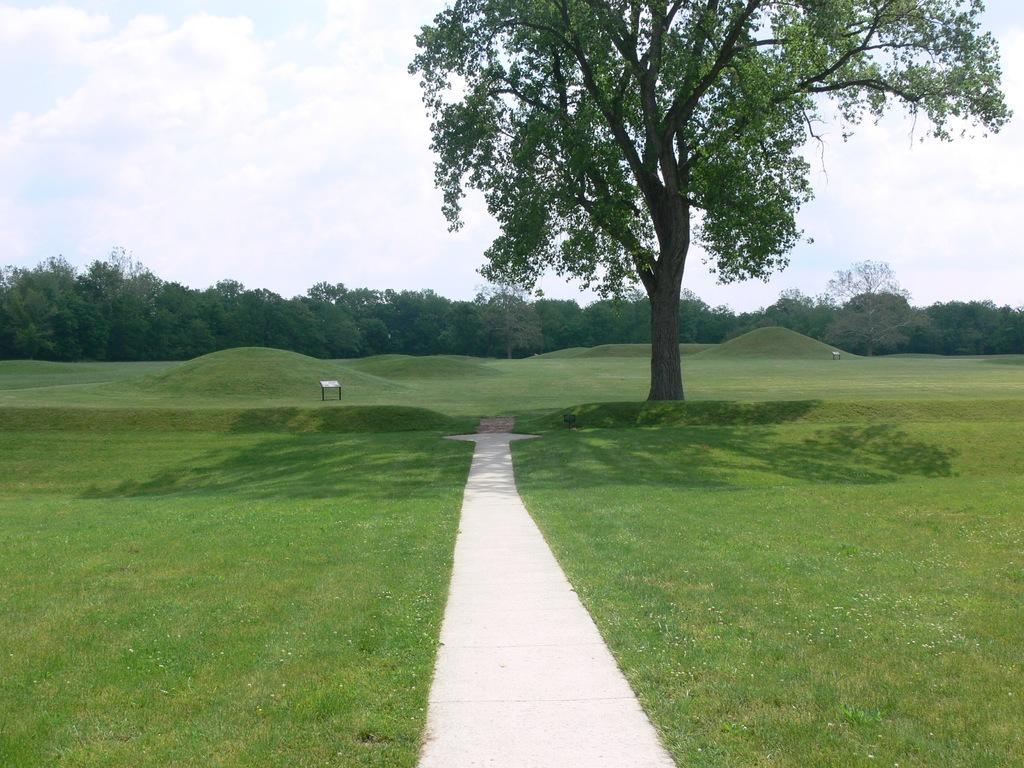In one or two sentences, can you explain what this image depicts? In the picture we can see a grass surface in the middle of it, we can see a pathway and beside it, we can see a tree and far away from it, we can see full of trees and behind it we can see a sky with clouds. 